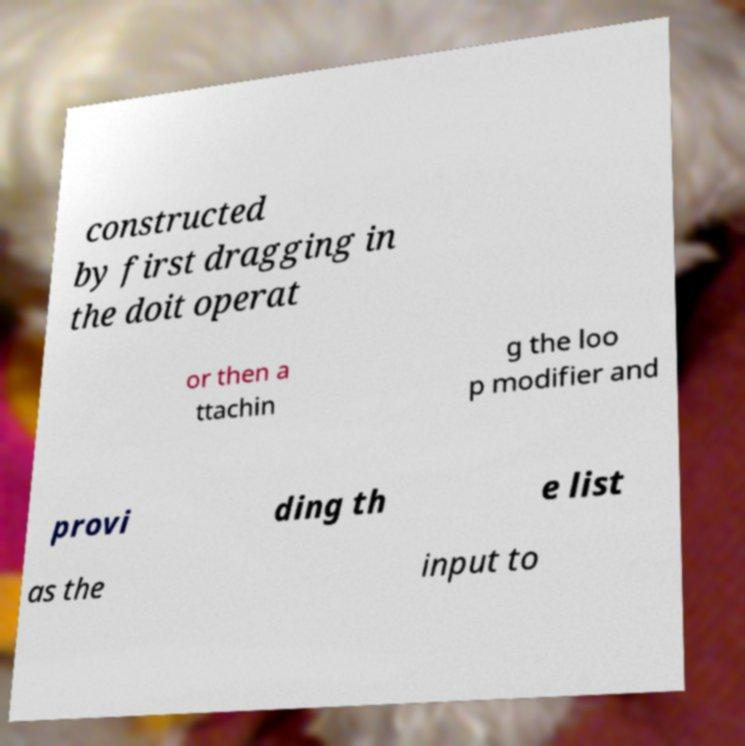Could you extract and type out the text from this image? constructed by first dragging in the doit operat or then a ttachin g the loo p modifier and provi ding th e list as the input to 